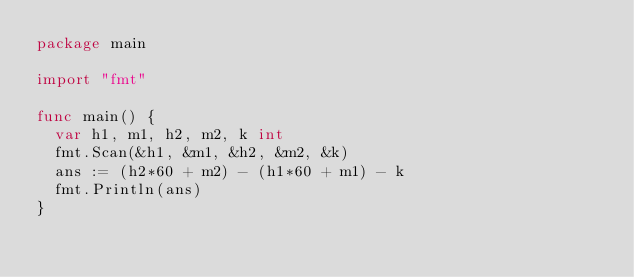<code> <loc_0><loc_0><loc_500><loc_500><_Go_>package main

import "fmt"

func main() {
	var h1, m1, h2, m2, k int
	fmt.Scan(&h1, &m1, &h2, &m2, &k)
	ans := (h2*60 + m2) - (h1*60 + m1) - k
	fmt.Println(ans)
}
</code> 